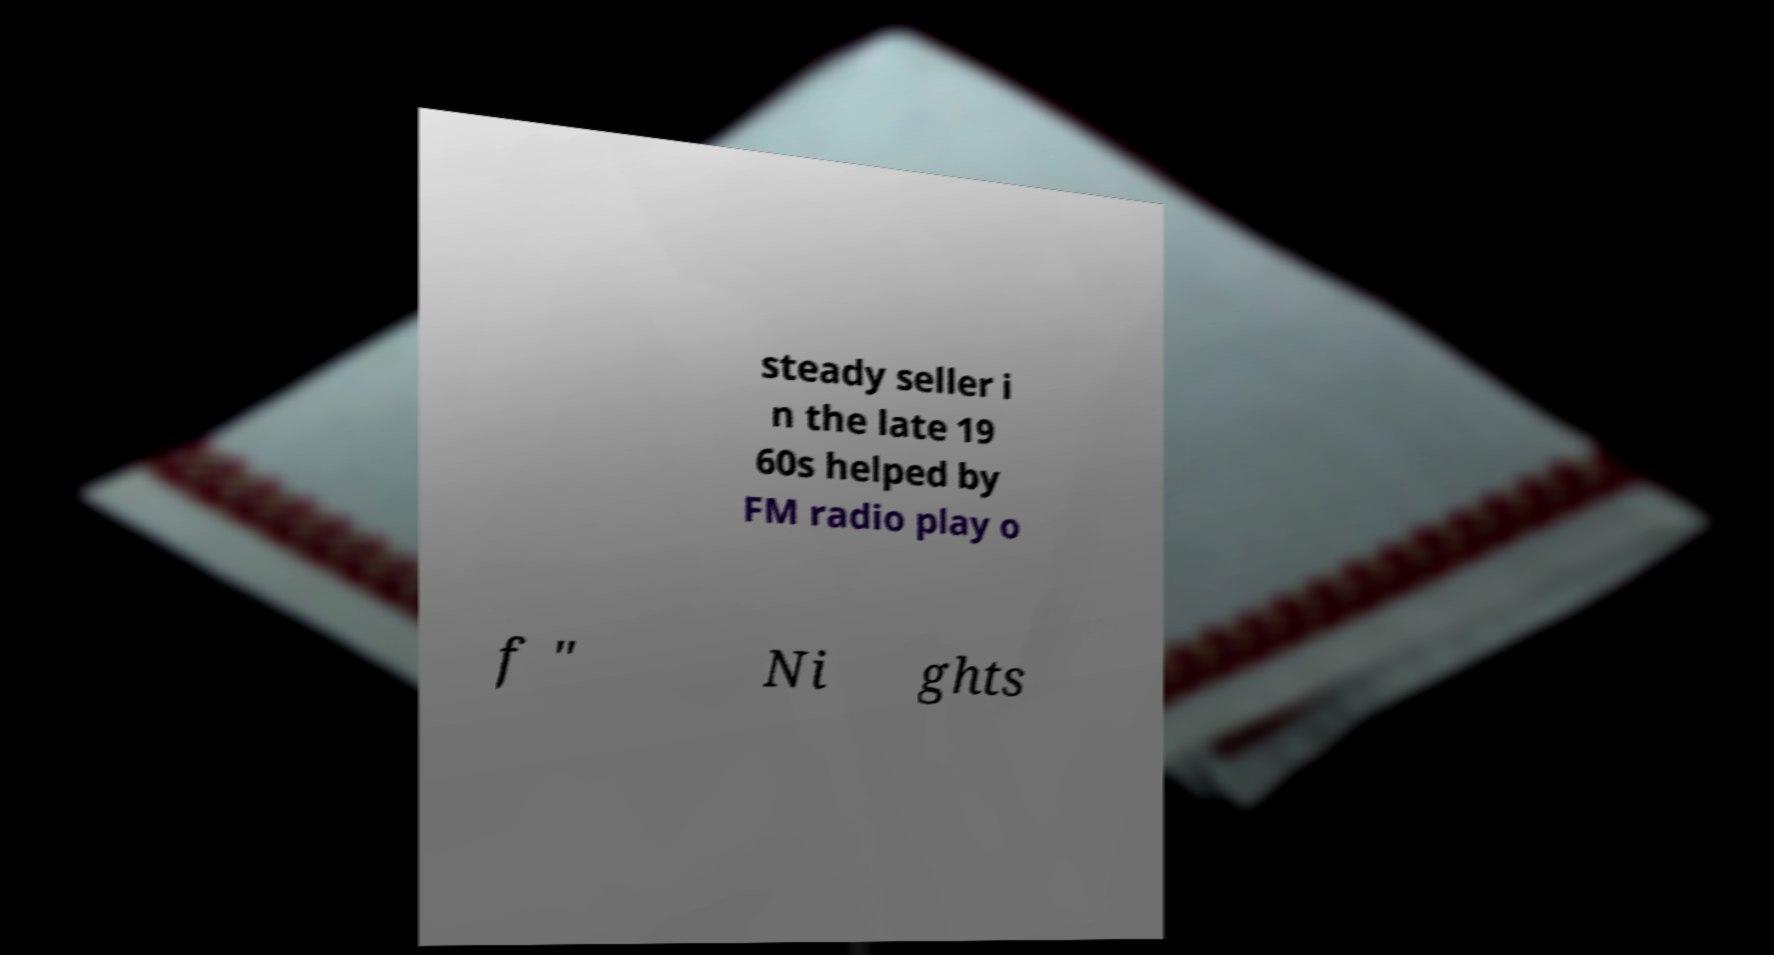What messages or text are displayed in this image? I need them in a readable, typed format. steady seller i n the late 19 60s helped by FM radio play o f " Ni ghts 